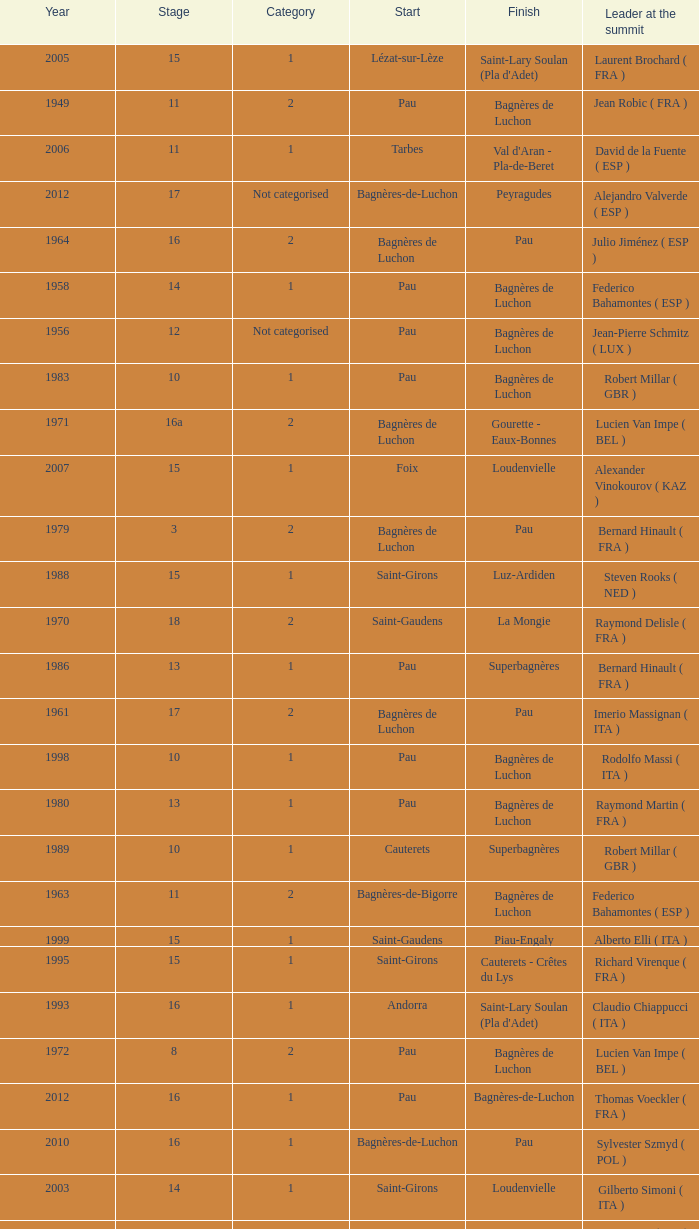What category was in 1964? 2.0. 